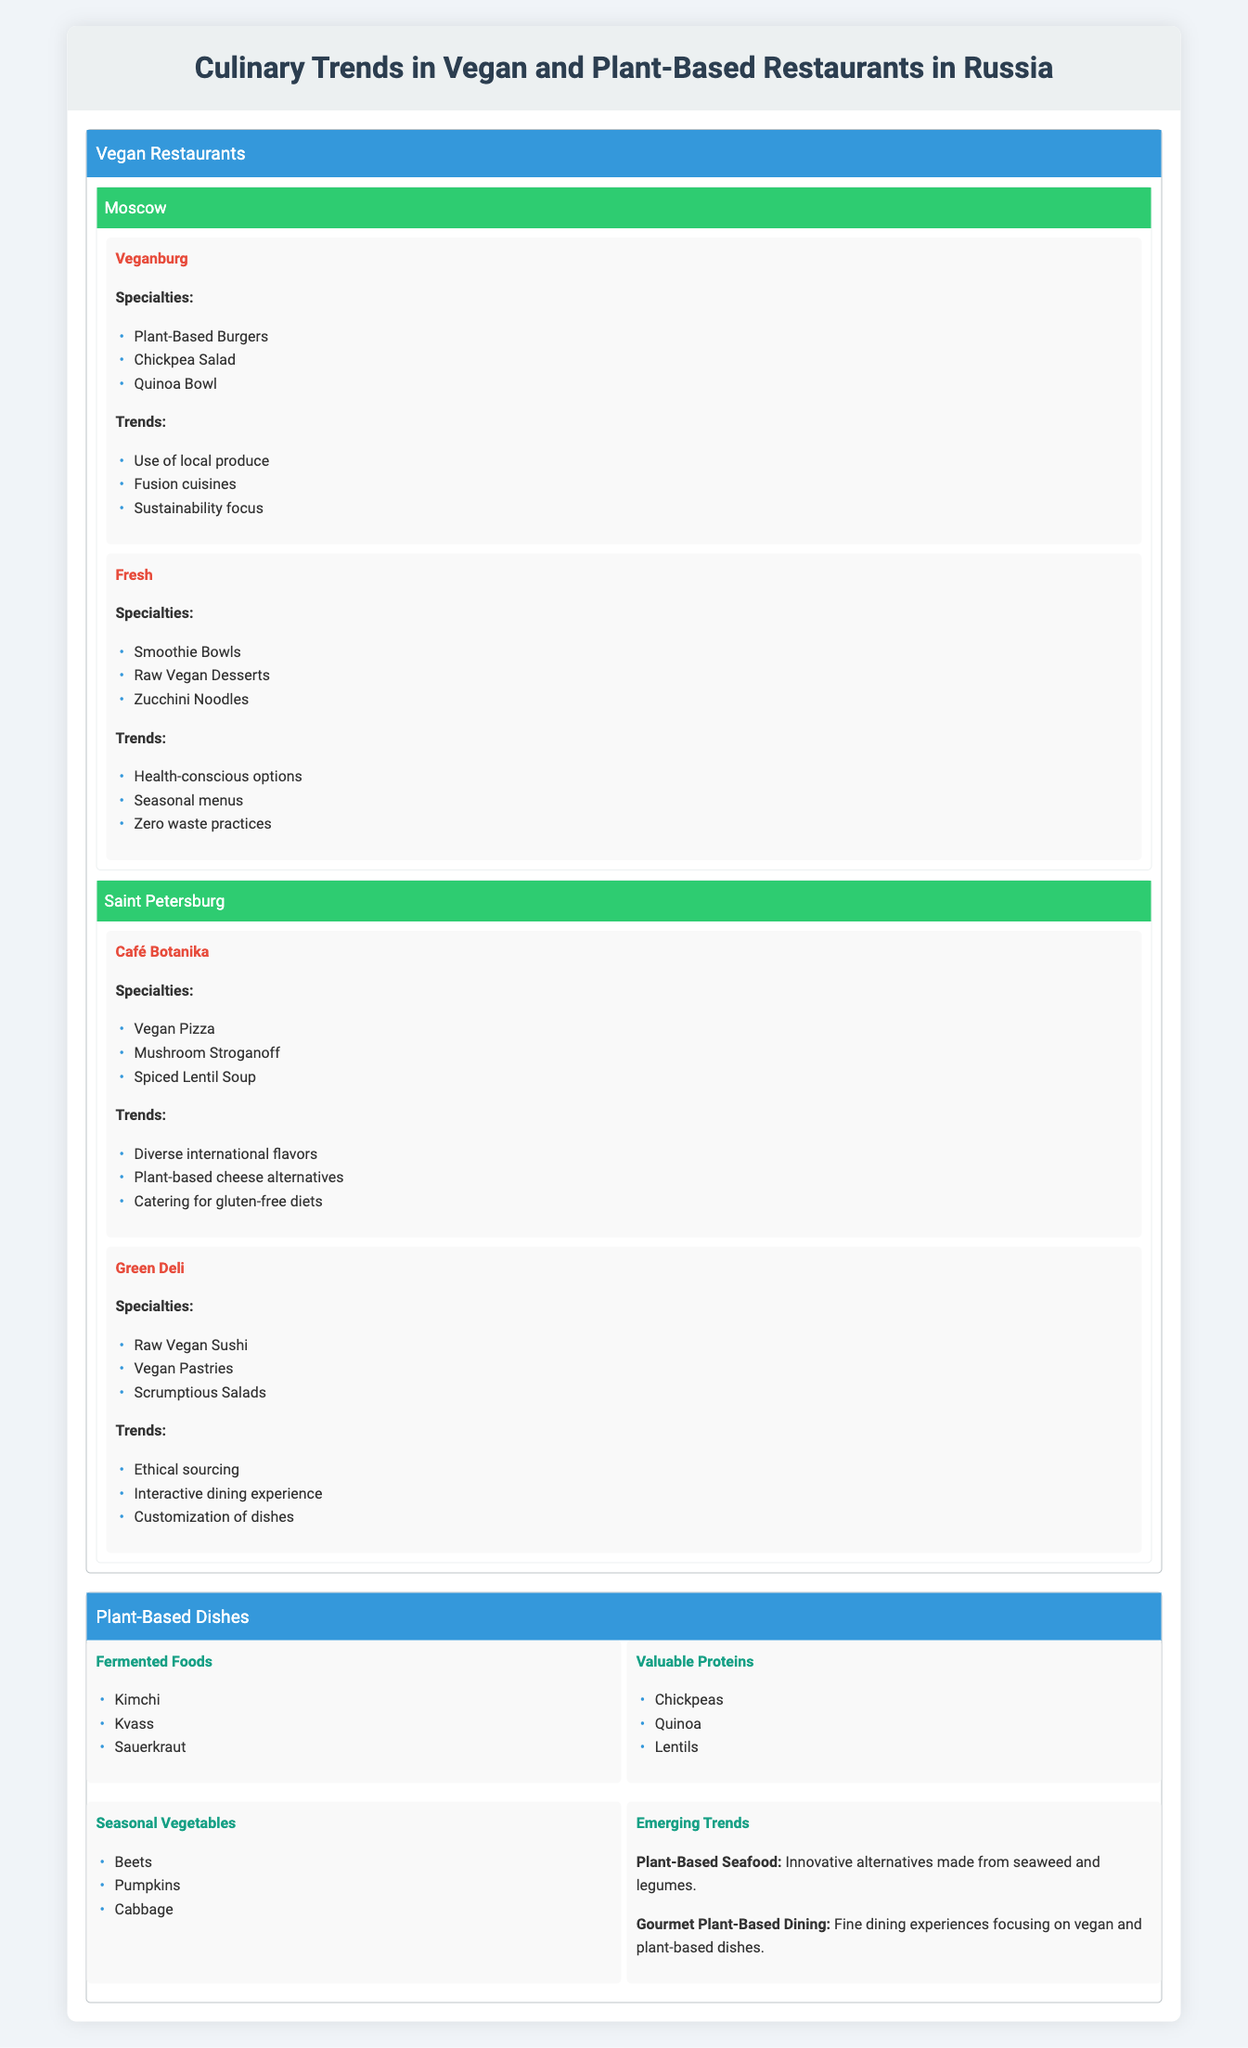What are the specialties offered by Veganburg? The table lists Veganburg under the popular establishments in Moscow. Its specialties include Plant-Based Burgers, Chickpea Salad, and Quinoa Bowl.
Answer: Plant-Based Burgers, Chickpea Salad, Quinoa Bowl Which city has a restaurant named Green Deli? Green Deli is mentioned in the section for popular establishments in Saint Petersburg.
Answer: Saint Petersburg Do all vegan restaurants listed focus on sustainability? In the information provided, only Veganburg and Fresh from Moscow specifically mention sustainability and zero waste practices. The other establishments do not explicitly mention sustainability. Thus, the statement is false.
Answer: No What are the trends associated with Café Botanika? Café Botanika in Saint Petersburg has three identified trends: Diverse international flavors, Plant-based cheese alternatives, and Catering for gluten-free diets.
Answer: Diverse international flavors, Plant-based cheese alternatives, Catering for gluten-free diets How many plant-based types are listed in the Plant-Based Dishes section? The Plant-Based Dishes section lists three popular types: Fermented Foods, Valuable Proteins, and Seasonal Vegetables. Plus, there are two emerging trends. This sums to a total of five categories.
Answer: 5 Which specialties are offered at the restaurant Fresh? Fresh in Moscow offers Smoothie Bowls, Raw Vegan Desserts, and Zucchini Noodles as its specialties.
Answer: Smoothie Bowls, Raw Vegan Desserts, Zucchini Noodles Are plant-based seafood and gourmet plant-based dining emerging trends? The table states that both Plant-Based Seafood and Gourmet Plant-Based Dining are mentioned as emerging trends, which confirms the statement is true.
Answer: Yes What cuisines are mentioned as trends in the vegan restaurants from Moscow? The trends for the vegan restaurants in Moscow include Use of local produce, Fusion cuisines, and Sustainability focus, as seen with Veganburg and Fresh.
Answer: Use of local produce, Fusion cuisines, Sustainability focus What specialty items are included under the Valuable Proteins? Under the Valuable Proteins category, the following items are listed: Chickpeas, Quinoa, and Lentils.
Answer: Chickpeas, Quinoa, Lentils 